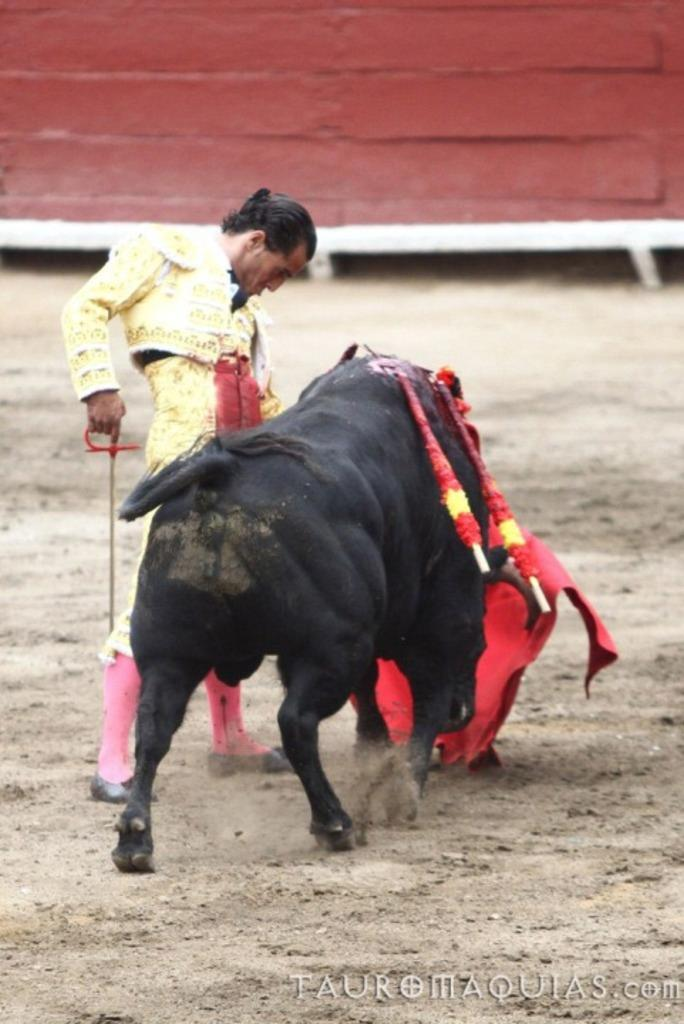What is the man in the image doing? The man is standing and holding an object in the image. What animal is present in the image? There is a bull in the image. What color is the wall in the background of the image? The wall in the background of the image is red. What can be found at the bottom of the image? There is text visible at the bottom of the image. How many rings are visible on the bull's nose in the image? There are no rings visible on the bull's nose in the image. What type of tent can be seen in the background of the image? There is no tent present in the image; it features a red wall in the background. 